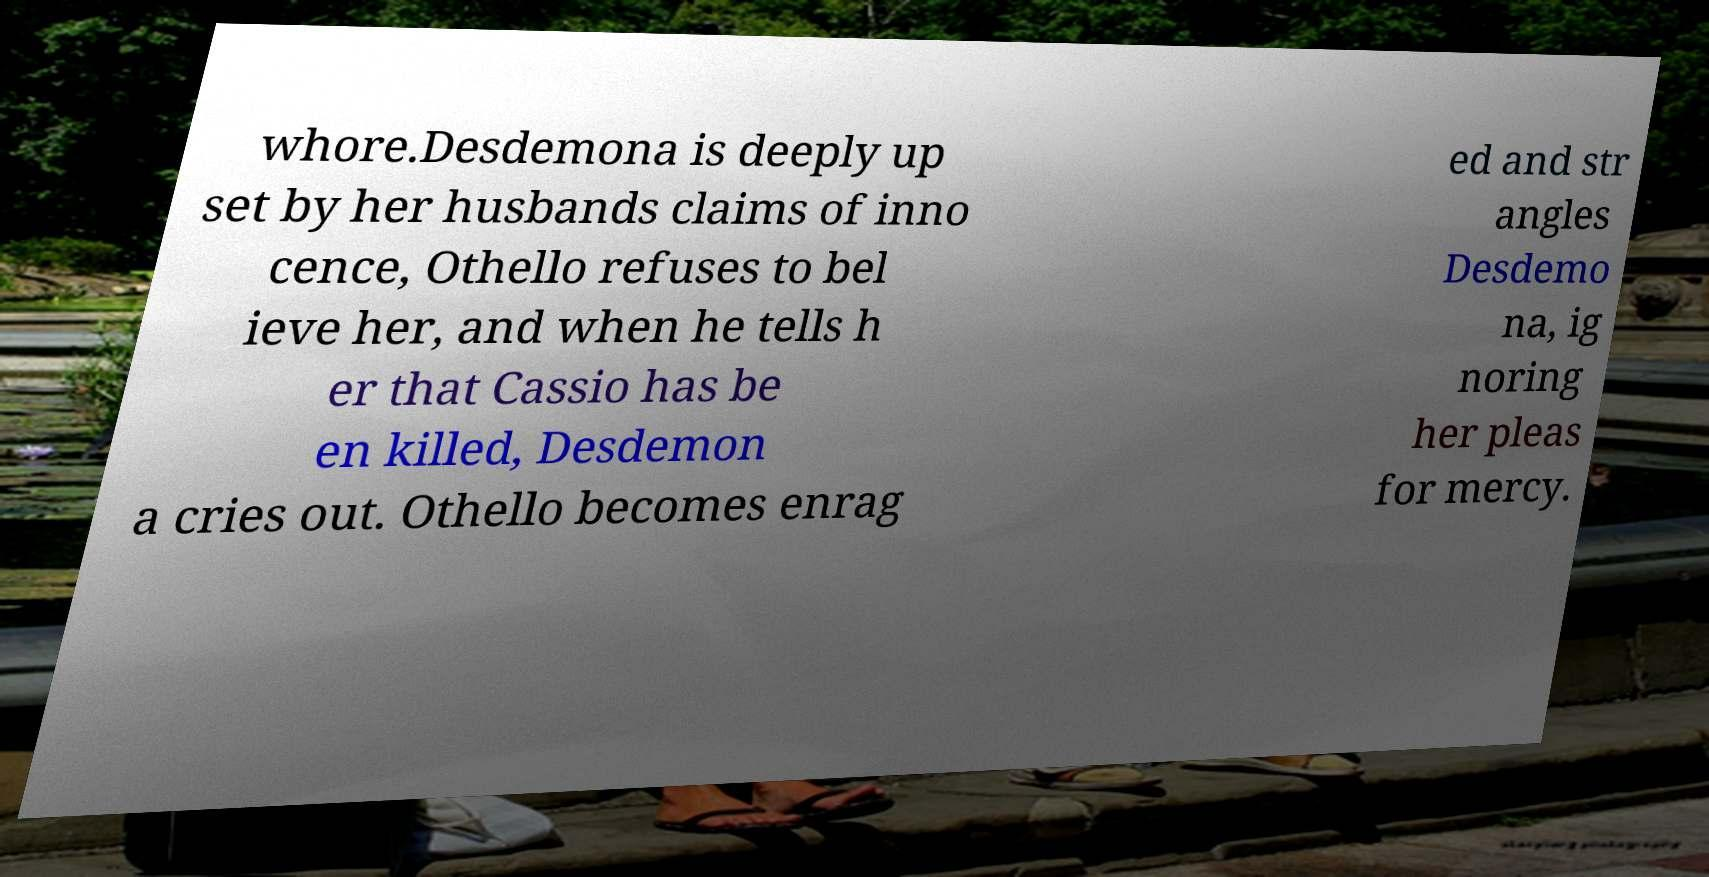Can you accurately transcribe the text from the provided image for me? whore.Desdemona is deeply up set by her husbands claims of inno cence, Othello refuses to bel ieve her, and when he tells h er that Cassio has be en killed, Desdemon a cries out. Othello becomes enrag ed and str angles Desdemo na, ig noring her pleas for mercy. 